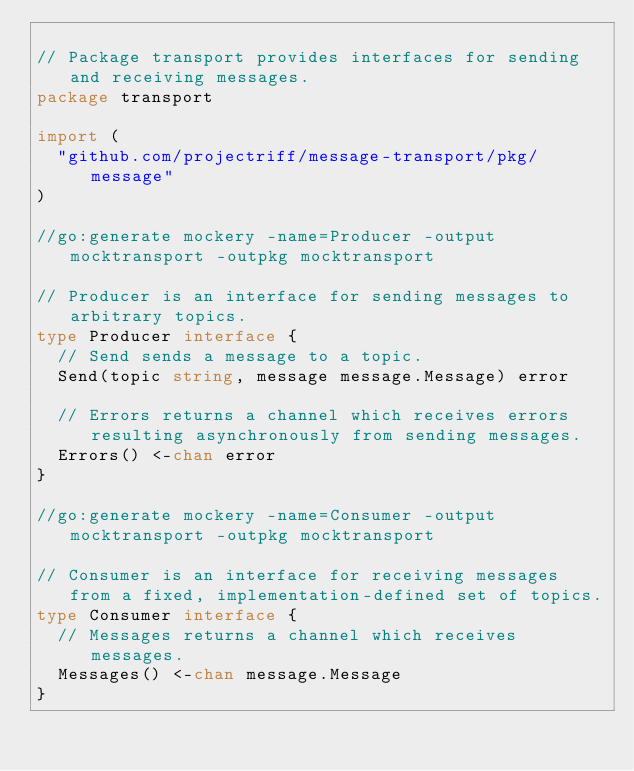<code> <loc_0><loc_0><loc_500><loc_500><_Go_>
// Package transport provides interfaces for sending and receiving messages.
package transport

import (
	"github.com/projectriff/message-transport/pkg/message"
)

//go:generate mockery -name=Producer -output mocktransport -outpkg mocktransport

// Producer is an interface for sending messages to arbitrary topics.
type Producer interface {
	// Send sends a message to a topic.
	Send(topic string, message message.Message) error

	// Errors returns a channel which receives errors resulting asynchronously from sending messages.
	Errors() <-chan error
}

//go:generate mockery -name=Consumer -output mocktransport -outpkg mocktransport

// Consumer is an interface for receiving messages from a fixed, implementation-defined set of topics.
type Consumer interface {
	// Messages returns a channel which receives messages.
	Messages() <-chan message.Message
}
</code> 